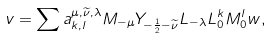<formula> <loc_0><loc_0><loc_500><loc_500>v = \sum a ^ { \mu , \widetilde { \nu } , \lambda } _ { k , l } M _ { - \mu } Y _ { - \frac { 1 } { 2 } - \widetilde { \nu } } L _ { - \lambda } L _ { 0 } ^ { k } M _ { 0 } ^ { l } w ,</formula> 